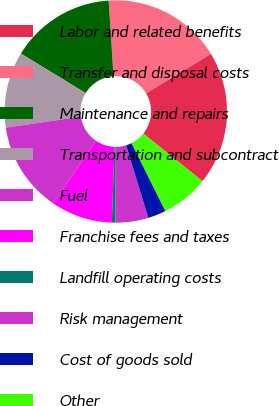Convert chart to OTSL. <chart><loc_0><loc_0><loc_500><loc_500><pie_chart><fcel>Labor and related benefits<fcel>Transfer and disposal costs<fcel>Maintenance and repairs<fcel>Transportation and subcontract<fcel>Fuel<fcel>Franchise fees and taxes<fcel>Landfill operating costs<fcel>Risk management<fcel>Cost of goods sold<fcel>Other<nl><fcel>19.46%<fcel>17.35%<fcel>15.25%<fcel>11.05%<fcel>13.15%<fcel>8.95%<fcel>0.54%<fcel>4.75%<fcel>2.65%<fcel>6.85%<nl></chart> 